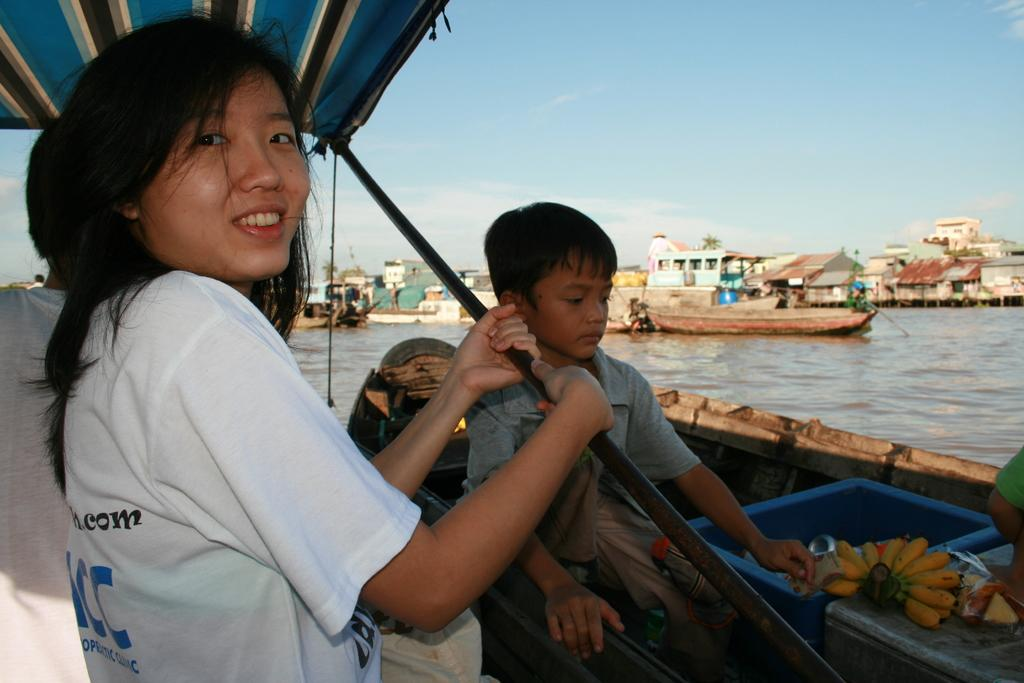Who is present in the boat in the image? There is a lady and a boy in the boat in the image. What type of structures can be seen in the image? There are sheds in the image. What is the primary mode of transportation in the image? There are boats on the water in the image. What can be seen in the background of the image? The sky is visible in the background of the image. What flavor of bottle is the boy holding in the image? There is no bottle present in the image, and therefore no flavor can be determined. 